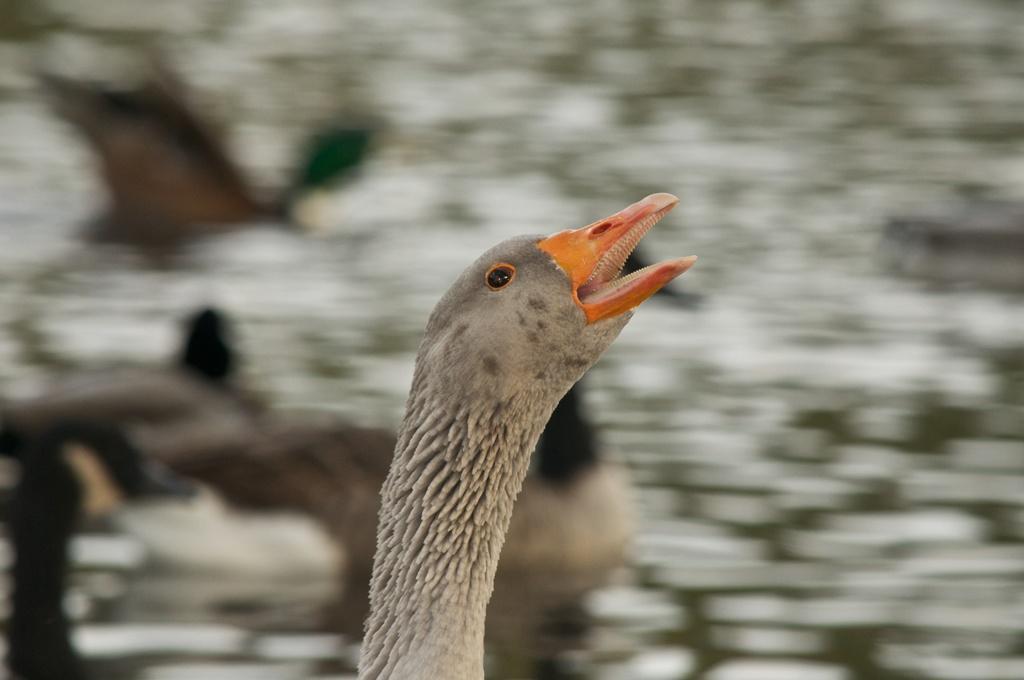Could you give a brief overview of what you see in this image? In the center of the image we can see a bird. 